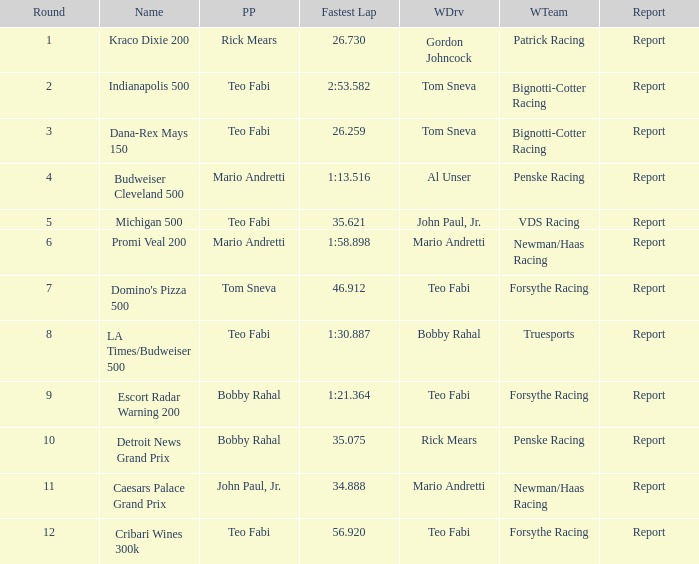What is the highest Rd that Tom Sneva had the pole position in? 7.0. Could you parse the entire table? {'header': ['Round', 'Name', 'PP', 'Fastest Lap', 'WDrv', 'WTeam', 'Report'], 'rows': [['1', 'Kraco Dixie 200', 'Rick Mears', '26.730', 'Gordon Johncock', 'Patrick Racing', 'Report'], ['2', 'Indianapolis 500', 'Teo Fabi', '2:53.582', 'Tom Sneva', 'Bignotti-Cotter Racing', 'Report'], ['3', 'Dana-Rex Mays 150', 'Teo Fabi', '26.259', 'Tom Sneva', 'Bignotti-Cotter Racing', 'Report'], ['4', 'Budweiser Cleveland 500', 'Mario Andretti', '1:13.516', 'Al Unser', 'Penske Racing', 'Report'], ['5', 'Michigan 500', 'Teo Fabi', '35.621', 'John Paul, Jr.', 'VDS Racing', 'Report'], ['6', 'Promi Veal 200', 'Mario Andretti', '1:58.898', 'Mario Andretti', 'Newman/Haas Racing', 'Report'], ['7', "Domino's Pizza 500", 'Tom Sneva', '46.912', 'Teo Fabi', 'Forsythe Racing', 'Report'], ['8', 'LA Times/Budweiser 500', 'Teo Fabi', '1:30.887', 'Bobby Rahal', 'Truesports', 'Report'], ['9', 'Escort Radar Warning 200', 'Bobby Rahal', '1:21.364', 'Teo Fabi', 'Forsythe Racing', 'Report'], ['10', 'Detroit News Grand Prix', 'Bobby Rahal', '35.075', 'Rick Mears', 'Penske Racing', 'Report'], ['11', 'Caesars Palace Grand Prix', 'John Paul, Jr.', '34.888', 'Mario Andretti', 'Newman/Haas Racing', 'Report'], ['12', 'Cribari Wines 300k', 'Teo Fabi', '56.920', 'Teo Fabi', 'Forsythe Racing', 'Report']]} 